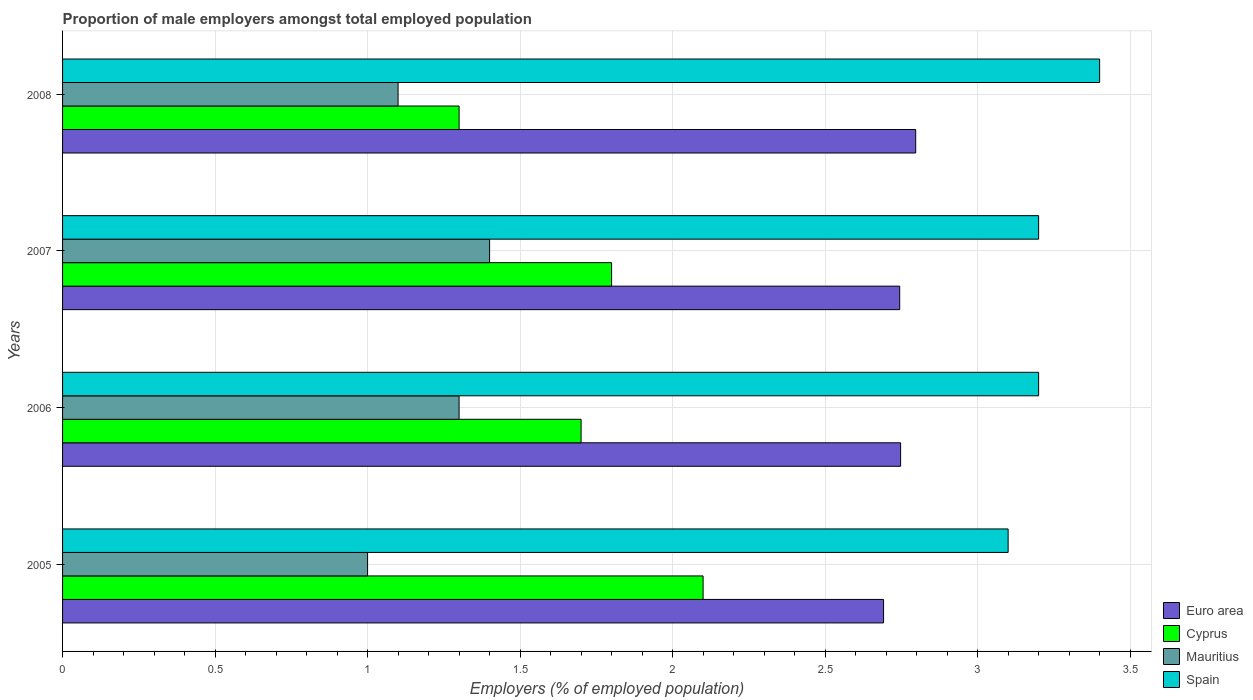How many different coloured bars are there?
Ensure brevity in your answer.  4. What is the proportion of male employers in Euro area in 2005?
Provide a short and direct response. 2.69. Across all years, what is the maximum proportion of male employers in Mauritius?
Your answer should be very brief. 1.4. Across all years, what is the minimum proportion of male employers in Cyprus?
Make the answer very short. 1.3. In which year was the proportion of male employers in Euro area maximum?
Offer a very short reply. 2008. In which year was the proportion of male employers in Euro area minimum?
Offer a very short reply. 2005. What is the total proportion of male employers in Mauritius in the graph?
Your answer should be compact. 4.8. What is the difference between the proportion of male employers in Spain in 2005 and that in 2006?
Your response must be concise. -0.1. What is the difference between the proportion of male employers in Cyprus in 2005 and the proportion of male employers in Mauritius in 2008?
Keep it short and to the point. 1. What is the average proportion of male employers in Euro area per year?
Keep it short and to the point. 2.75. In the year 2005, what is the difference between the proportion of male employers in Euro area and proportion of male employers in Cyprus?
Offer a terse response. 0.59. What is the ratio of the proportion of male employers in Mauritius in 2005 to that in 2007?
Ensure brevity in your answer.  0.71. Is the proportion of male employers in Euro area in 2006 less than that in 2008?
Ensure brevity in your answer.  Yes. What is the difference between the highest and the second highest proportion of male employers in Euro area?
Keep it short and to the point. 0.05. What is the difference between the highest and the lowest proportion of male employers in Cyprus?
Offer a terse response. 0.8. Is it the case that in every year, the sum of the proportion of male employers in Cyprus and proportion of male employers in Spain is greater than the sum of proportion of male employers in Mauritius and proportion of male employers in Euro area?
Provide a succinct answer. Yes. What does the 2nd bar from the top in 2008 represents?
Your answer should be compact. Mauritius. What does the 3rd bar from the bottom in 2006 represents?
Make the answer very short. Mauritius. Are all the bars in the graph horizontal?
Make the answer very short. Yes. How many years are there in the graph?
Your answer should be very brief. 4. Are the values on the major ticks of X-axis written in scientific E-notation?
Offer a terse response. No. Does the graph contain any zero values?
Keep it short and to the point. No. Where does the legend appear in the graph?
Offer a terse response. Bottom right. How many legend labels are there?
Offer a very short reply. 4. How are the legend labels stacked?
Your response must be concise. Vertical. What is the title of the graph?
Make the answer very short. Proportion of male employers amongst total employed population. Does "Seychelles" appear as one of the legend labels in the graph?
Provide a succinct answer. No. What is the label or title of the X-axis?
Ensure brevity in your answer.  Employers (% of employed population). What is the label or title of the Y-axis?
Offer a very short reply. Years. What is the Employers (% of employed population) of Euro area in 2005?
Give a very brief answer. 2.69. What is the Employers (% of employed population) of Cyprus in 2005?
Provide a succinct answer. 2.1. What is the Employers (% of employed population) of Mauritius in 2005?
Offer a very short reply. 1. What is the Employers (% of employed population) in Spain in 2005?
Give a very brief answer. 3.1. What is the Employers (% of employed population) in Euro area in 2006?
Offer a very short reply. 2.75. What is the Employers (% of employed population) of Cyprus in 2006?
Ensure brevity in your answer.  1.7. What is the Employers (% of employed population) of Mauritius in 2006?
Give a very brief answer. 1.3. What is the Employers (% of employed population) of Spain in 2006?
Offer a very short reply. 3.2. What is the Employers (% of employed population) of Euro area in 2007?
Your response must be concise. 2.74. What is the Employers (% of employed population) in Cyprus in 2007?
Give a very brief answer. 1.8. What is the Employers (% of employed population) of Mauritius in 2007?
Your answer should be compact. 1.4. What is the Employers (% of employed population) of Spain in 2007?
Make the answer very short. 3.2. What is the Employers (% of employed population) in Euro area in 2008?
Offer a terse response. 2.8. What is the Employers (% of employed population) in Cyprus in 2008?
Your response must be concise. 1.3. What is the Employers (% of employed population) of Mauritius in 2008?
Provide a short and direct response. 1.1. What is the Employers (% of employed population) in Spain in 2008?
Your response must be concise. 3.4. Across all years, what is the maximum Employers (% of employed population) in Euro area?
Ensure brevity in your answer.  2.8. Across all years, what is the maximum Employers (% of employed population) in Cyprus?
Your response must be concise. 2.1. Across all years, what is the maximum Employers (% of employed population) in Mauritius?
Give a very brief answer. 1.4. Across all years, what is the maximum Employers (% of employed population) in Spain?
Provide a short and direct response. 3.4. Across all years, what is the minimum Employers (% of employed population) in Euro area?
Offer a terse response. 2.69. Across all years, what is the minimum Employers (% of employed population) of Cyprus?
Give a very brief answer. 1.3. Across all years, what is the minimum Employers (% of employed population) of Spain?
Offer a very short reply. 3.1. What is the total Employers (% of employed population) in Euro area in the graph?
Offer a very short reply. 10.98. What is the total Employers (% of employed population) of Cyprus in the graph?
Offer a terse response. 6.9. What is the total Employers (% of employed population) in Mauritius in the graph?
Make the answer very short. 4.8. What is the difference between the Employers (% of employed population) of Euro area in 2005 and that in 2006?
Provide a short and direct response. -0.06. What is the difference between the Employers (% of employed population) in Cyprus in 2005 and that in 2006?
Ensure brevity in your answer.  0.4. What is the difference between the Employers (% of employed population) in Mauritius in 2005 and that in 2006?
Your answer should be compact. -0.3. What is the difference between the Employers (% of employed population) of Spain in 2005 and that in 2006?
Offer a terse response. -0.1. What is the difference between the Employers (% of employed population) of Euro area in 2005 and that in 2007?
Your answer should be very brief. -0.05. What is the difference between the Employers (% of employed population) of Cyprus in 2005 and that in 2007?
Your response must be concise. 0.3. What is the difference between the Employers (% of employed population) of Mauritius in 2005 and that in 2007?
Offer a terse response. -0.4. What is the difference between the Employers (% of employed population) in Spain in 2005 and that in 2007?
Offer a terse response. -0.1. What is the difference between the Employers (% of employed population) of Euro area in 2005 and that in 2008?
Your answer should be very brief. -0.11. What is the difference between the Employers (% of employed population) of Cyprus in 2005 and that in 2008?
Your answer should be very brief. 0.8. What is the difference between the Employers (% of employed population) in Mauritius in 2005 and that in 2008?
Ensure brevity in your answer.  -0.1. What is the difference between the Employers (% of employed population) of Spain in 2005 and that in 2008?
Your answer should be compact. -0.3. What is the difference between the Employers (% of employed population) of Euro area in 2006 and that in 2007?
Your answer should be very brief. 0. What is the difference between the Employers (% of employed population) in Spain in 2006 and that in 2007?
Provide a short and direct response. 0. What is the difference between the Employers (% of employed population) of Euro area in 2006 and that in 2008?
Keep it short and to the point. -0.05. What is the difference between the Employers (% of employed population) in Cyprus in 2006 and that in 2008?
Your response must be concise. 0.4. What is the difference between the Employers (% of employed population) of Mauritius in 2006 and that in 2008?
Your answer should be compact. 0.2. What is the difference between the Employers (% of employed population) of Spain in 2006 and that in 2008?
Keep it short and to the point. -0.2. What is the difference between the Employers (% of employed population) in Euro area in 2007 and that in 2008?
Offer a very short reply. -0.05. What is the difference between the Employers (% of employed population) of Cyprus in 2007 and that in 2008?
Ensure brevity in your answer.  0.5. What is the difference between the Employers (% of employed population) of Spain in 2007 and that in 2008?
Make the answer very short. -0.2. What is the difference between the Employers (% of employed population) of Euro area in 2005 and the Employers (% of employed population) of Cyprus in 2006?
Provide a short and direct response. 0.99. What is the difference between the Employers (% of employed population) of Euro area in 2005 and the Employers (% of employed population) of Mauritius in 2006?
Your response must be concise. 1.39. What is the difference between the Employers (% of employed population) of Euro area in 2005 and the Employers (% of employed population) of Spain in 2006?
Keep it short and to the point. -0.51. What is the difference between the Employers (% of employed population) of Cyprus in 2005 and the Employers (% of employed population) of Mauritius in 2006?
Your answer should be compact. 0.8. What is the difference between the Employers (% of employed population) in Mauritius in 2005 and the Employers (% of employed population) in Spain in 2006?
Provide a succinct answer. -2.2. What is the difference between the Employers (% of employed population) in Euro area in 2005 and the Employers (% of employed population) in Cyprus in 2007?
Your response must be concise. 0.89. What is the difference between the Employers (% of employed population) of Euro area in 2005 and the Employers (% of employed population) of Mauritius in 2007?
Offer a terse response. 1.29. What is the difference between the Employers (% of employed population) in Euro area in 2005 and the Employers (% of employed population) in Spain in 2007?
Ensure brevity in your answer.  -0.51. What is the difference between the Employers (% of employed population) in Cyprus in 2005 and the Employers (% of employed population) in Mauritius in 2007?
Give a very brief answer. 0.7. What is the difference between the Employers (% of employed population) in Euro area in 2005 and the Employers (% of employed population) in Cyprus in 2008?
Offer a terse response. 1.39. What is the difference between the Employers (% of employed population) of Euro area in 2005 and the Employers (% of employed population) of Mauritius in 2008?
Offer a very short reply. 1.59. What is the difference between the Employers (% of employed population) of Euro area in 2005 and the Employers (% of employed population) of Spain in 2008?
Provide a short and direct response. -0.71. What is the difference between the Employers (% of employed population) of Cyprus in 2005 and the Employers (% of employed population) of Mauritius in 2008?
Provide a succinct answer. 1. What is the difference between the Employers (% of employed population) of Euro area in 2006 and the Employers (% of employed population) of Cyprus in 2007?
Offer a terse response. 0.95. What is the difference between the Employers (% of employed population) in Euro area in 2006 and the Employers (% of employed population) in Mauritius in 2007?
Offer a very short reply. 1.35. What is the difference between the Employers (% of employed population) of Euro area in 2006 and the Employers (% of employed population) of Spain in 2007?
Offer a very short reply. -0.45. What is the difference between the Employers (% of employed population) of Mauritius in 2006 and the Employers (% of employed population) of Spain in 2007?
Give a very brief answer. -1.9. What is the difference between the Employers (% of employed population) in Euro area in 2006 and the Employers (% of employed population) in Cyprus in 2008?
Give a very brief answer. 1.45. What is the difference between the Employers (% of employed population) of Euro area in 2006 and the Employers (% of employed population) of Mauritius in 2008?
Give a very brief answer. 1.65. What is the difference between the Employers (% of employed population) of Euro area in 2006 and the Employers (% of employed population) of Spain in 2008?
Your response must be concise. -0.65. What is the difference between the Employers (% of employed population) in Cyprus in 2006 and the Employers (% of employed population) in Mauritius in 2008?
Give a very brief answer. 0.6. What is the difference between the Employers (% of employed population) in Euro area in 2007 and the Employers (% of employed population) in Cyprus in 2008?
Your answer should be very brief. 1.44. What is the difference between the Employers (% of employed population) in Euro area in 2007 and the Employers (% of employed population) in Mauritius in 2008?
Offer a terse response. 1.64. What is the difference between the Employers (% of employed population) of Euro area in 2007 and the Employers (% of employed population) of Spain in 2008?
Provide a succinct answer. -0.66. What is the difference between the Employers (% of employed population) of Cyprus in 2007 and the Employers (% of employed population) of Spain in 2008?
Your answer should be compact. -1.6. What is the average Employers (% of employed population) of Euro area per year?
Give a very brief answer. 2.75. What is the average Employers (% of employed population) in Cyprus per year?
Your answer should be very brief. 1.73. What is the average Employers (% of employed population) in Mauritius per year?
Offer a terse response. 1.2. What is the average Employers (% of employed population) of Spain per year?
Offer a terse response. 3.23. In the year 2005, what is the difference between the Employers (% of employed population) of Euro area and Employers (% of employed population) of Cyprus?
Make the answer very short. 0.59. In the year 2005, what is the difference between the Employers (% of employed population) in Euro area and Employers (% of employed population) in Mauritius?
Ensure brevity in your answer.  1.69. In the year 2005, what is the difference between the Employers (% of employed population) in Euro area and Employers (% of employed population) in Spain?
Your response must be concise. -0.41. In the year 2005, what is the difference between the Employers (% of employed population) of Cyprus and Employers (% of employed population) of Spain?
Your answer should be very brief. -1. In the year 2006, what is the difference between the Employers (% of employed population) in Euro area and Employers (% of employed population) in Cyprus?
Provide a short and direct response. 1.05. In the year 2006, what is the difference between the Employers (% of employed population) in Euro area and Employers (% of employed population) in Mauritius?
Offer a terse response. 1.45. In the year 2006, what is the difference between the Employers (% of employed population) of Euro area and Employers (% of employed population) of Spain?
Provide a succinct answer. -0.45. In the year 2006, what is the difference between the Employers (% of employed population) of Mauritius and Employers (% of employed population) of Spain?
Your answer should be very brief. -1.9. In the year 2007, what is the difference between the Employers (% of employed population) of Euro area and Employers (% of employed population) of Cyprus?
Your response must be concise. 0.94. In the year 2007, what is the difference between the Employers (% of employed population) of Euro area and Employers (% of employed population) of Mauritius?
Provide a succinct answer. 1.34. In the year 2007, what is the difference between the Employers (% of employed population) of Euro area and Employers (% of employed population) of Spain?
Provide a short and direct response. -0.46. In the year 2008, what is the difference between the Employers (% of employed population) in Euro area and Employers (% of employed population) in Cyprus?
Ensure brevity in your answer.  1.5. In the year 2008, what is the difference between the Employers (% of employed population) in Euro area and Employers (% of employed population) in Mauritius?
Your response must be concise. 1.7. In the year 2008, what is the difference between the Employers (% of employed population) in Euro area and Employers (% of employed population) in Spain?
Provide a succinct answer. -0.6. In the year 2008, what is the difference between the Employers (% of employed population) in Cyprus and Employers (% of employed population) in Mauritius?
Give a very brief answer. 0.2. In the year 2008, what is the difference between the Employers (% of employed population) of Cyprus and Employers (% of employed population) of Spain?
Provide a succinct answer. -2.1. What is the ratio of the Employers (% of employed population) of Euro area in 2005 to that in 2006?
Your response must be concise. 0.98. What is the ratio of the Employers (% of employed population) of Cyprus in 2005 to that in 2006?
Keep it short and to the point. 1.24. What is the ratio of the Employers (% of employed population) in Mauritius in 2005 to that in 2006?
Offer a terse response. 0.77. What is the ratio of the Employers (% of employed population) of Spain in 2005 to that in 2006?
Provide a succinct answer. 0.97. What is the ratio of the Employers (% of employed population) of Euro area in 2005 to that in 2007?
Give a very brief answer. 0.98. What is the ratio of the Employers (% of employed population) in Cyprus in 2005 to that in 2007?
Provide a succinct answer. 1.17. What is the ratio of the Employers (% of employed population) in Spain in 2005 to that in 2007?
Ensure brevity in your answer.  0.97. What is the ratio of the Employers (% of employed population) in Euro area in 2005 to that in 2008?
Offer a terse response. 0.96. What is the ratio of the Employers (% of employed population) of Cyprus in 2005 to that in 2008?
Ensure brevity in your answer.  1.62. What is the ratio of the Employers (% of employed population) in Spain in 2005 to that in 2008?
Offer a very short reply. 0.91. What is the ratio of the Employers (% of employed population) in Mauritius in 2006 to that in 2007?
Make the answer very short. 0.93. What is the ratio of the Employers (% of employed population) in Euro area in 2006 to that in 2008?
Your answer should be compact. 0.98. What is the ratio of the Employers (% of employed population) of Cyprus in 2006 to that in 2008?
Your response must be concise. 1.31. What is the ratio of the Employers (% of employed population) in Mauritius in 2006 to that in 2008?
Provide a short and direct response. 1.18. What is the ratio of the Employers (% of employed population) of Euro area in 2007 to that in 2008?
Provide a succinct answer. 0.98. What is the ratio of the Employers (% of employed population) of Cyprus in 2007 to that in 2008?
Make the answer very short. 1.38. What is the ratio of the Employers (% of employed population) in Mauritius in 2007 to that in 2008?
Your answer should be compact. 1.27. What is the ratio of the Employers (% of employed population) of Spain in 2007 to that in 2008?
Provide a succinct answer. 0.94. What is the difference between the highest and the second highest Employers (% of employed population) of Euro area?
Keep it short and to the point. 0.05. What is the difference between the highest and the second highest Employers (% of employed population) in Cyprus?
Provide a succinct answer. 0.3. What is the difference between the highest and the lowest Employers (% of employed population) of Euro area?
Provide a short and direct response. 0.11. 